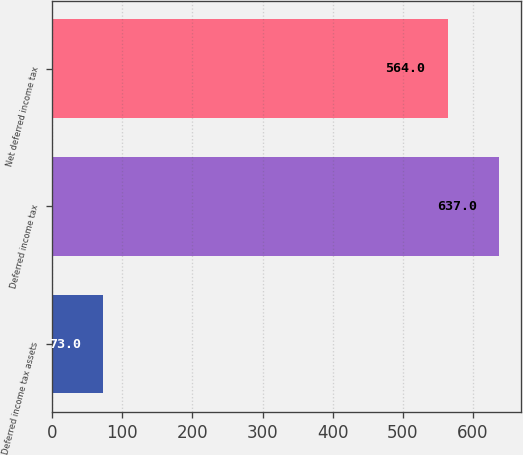<chart> <loc_0><loc_0><loc_500><loc_500><bar_chart><fcel>Deferred income tax assets<fcel>Deferred income tax<fcel>Net deferred income tax<nl><fcel>73<fcel>637<fcel>564<nl></chart> 